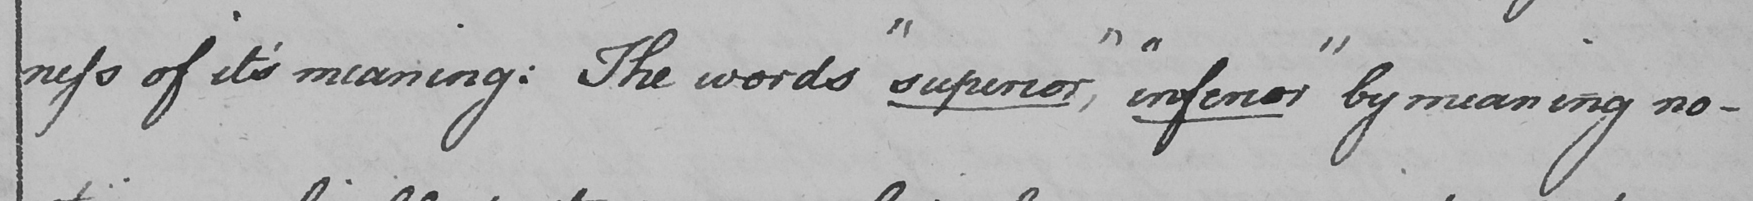Can you read and transcribe this handwriting? -ness of it ' s meaning :  The words  " superior , "   " inferior "  by meaning no- 